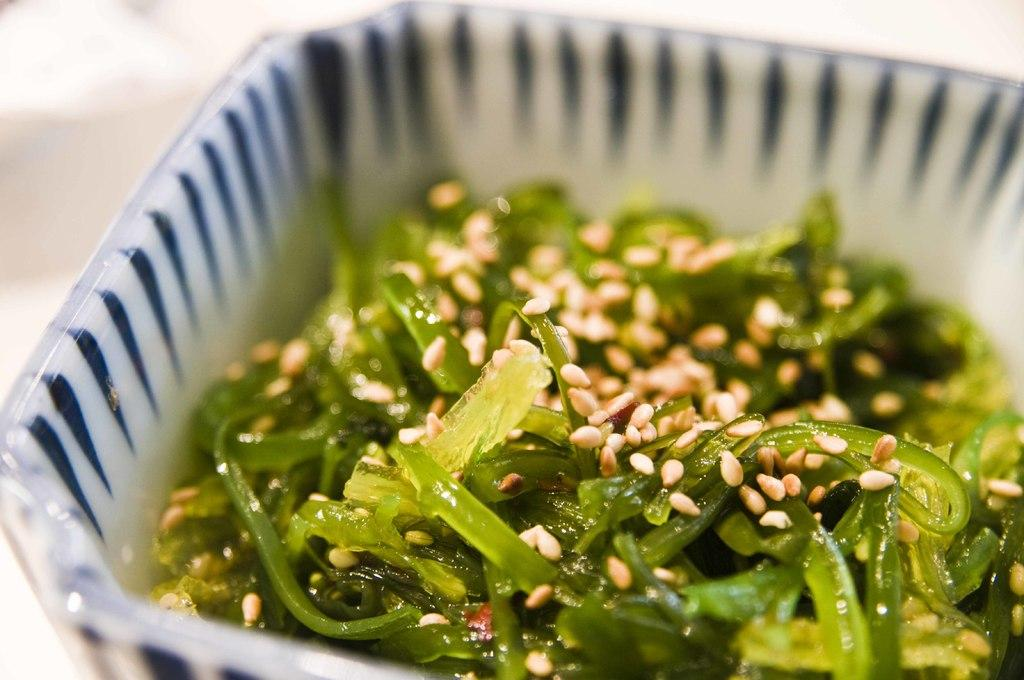What is in the bowl that is visible in the image? There are food items in a bowl in the image. What type of nut can be seen hanging from the branch in the image? There is no nut or branch present in the image; it only features food items in a bowl. 